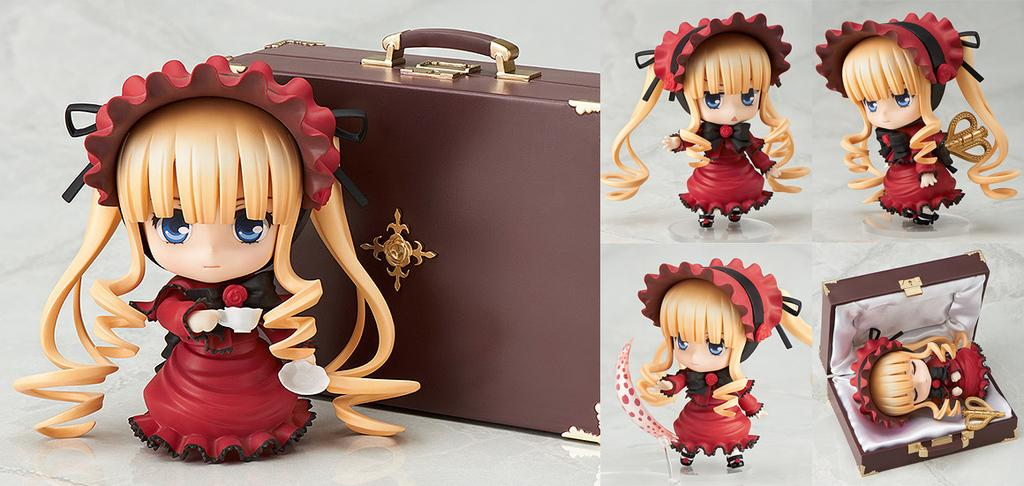What is present in the first image of the collage? There is a doll and a suitcase behind the doll in the first image. What is present in the second image of the collage? There are dolls and a suitcase in the second image, with a doll inside the suitcase. Can you describe the relationship between the dolls and the suitcase in the second image? In the second image, there is a doll inside the suitcase. What type of music can be heard coming from the doll in the first image? There is no music present in the image; it is a doll and a suitcase. How many people are visible in the images? There are no people visible in the images, only dolls and suitcases. 